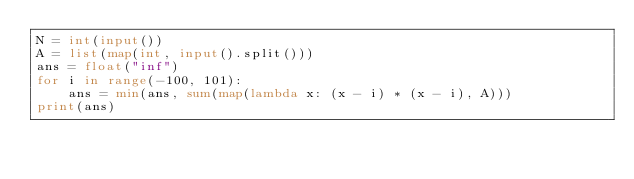Convert code to text. <code><loc_0><loc_0><loc_500><loc_500><_Python_>N = int(input())
A = list(map(int, input().split()))
ans = float("inf")
for i in range(-100, 101):
    ans = min(ans, sum(map(lambda x: (x - i) * (x - i), A)))
print(ans)
</code> 